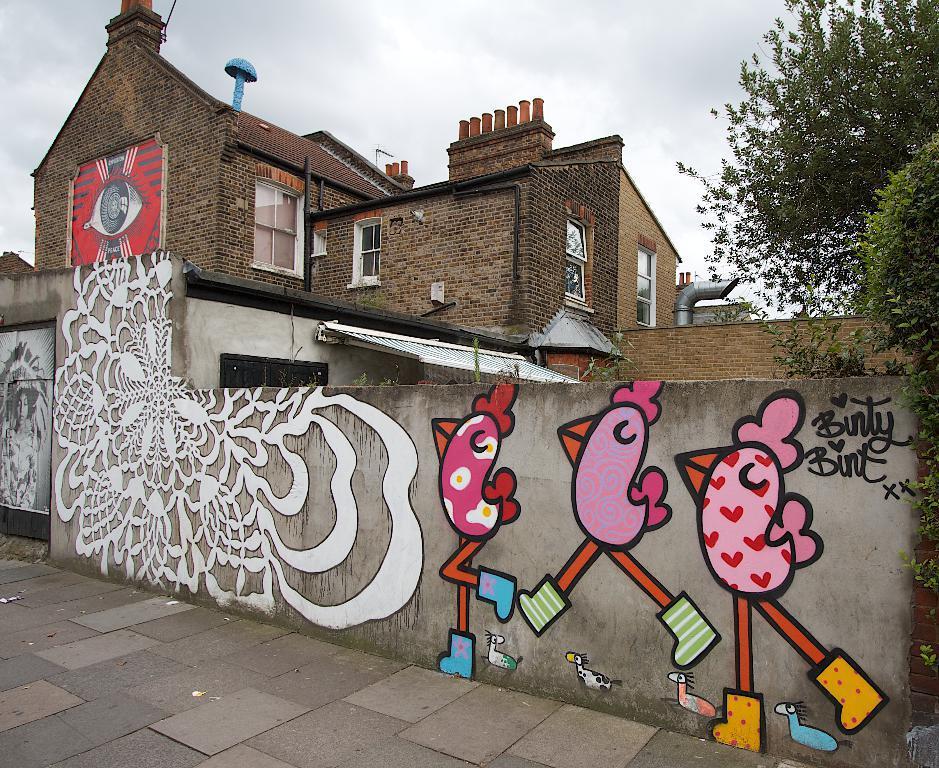Please provide a concise description of this image. Here I can see a wall which consists of paintings on it. At the bottom of the image I can see the ground. In the background there is a building along with the windows. On the right side there are some trees. On the top of the image I can see the sky. 